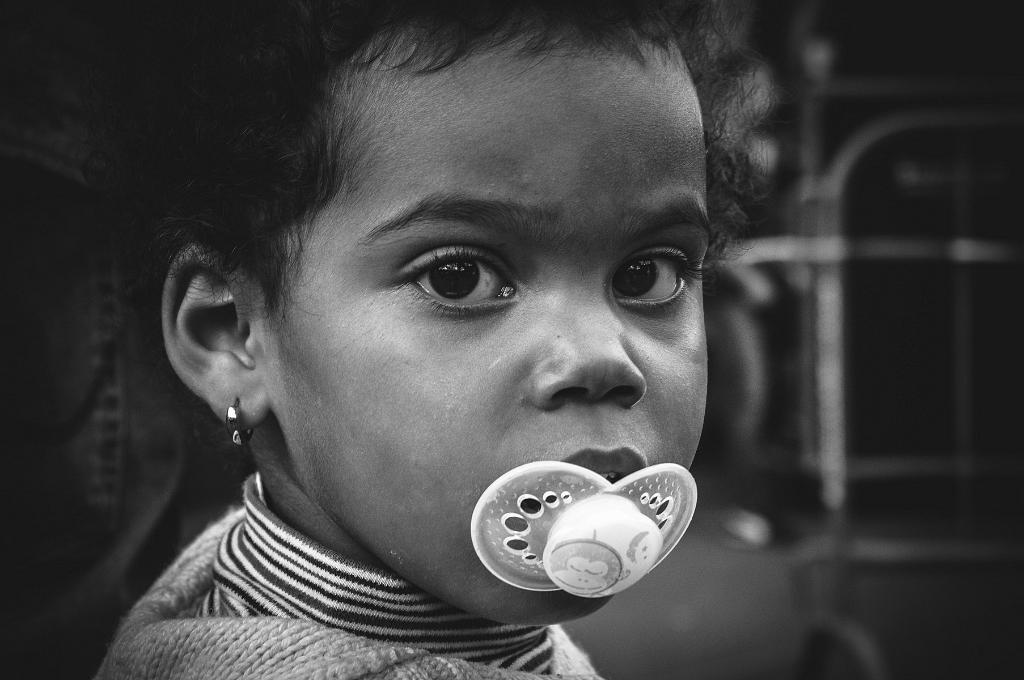What is the main subject of the picture? The main subject of the picture is a kid. What object is present in the picture related to feeding? There is a nipple in the picture. What is the color scheme of the picture? The picture is black and white. What type of stocking can be seen on the kid's leg in the image? There is no stocking visible on the kid's leg in the image. Can you describe the veins visible on the kid's hand in the image? There is no visible hand or veins in the image, as it is black and white and only shows a kid and a nipple. 